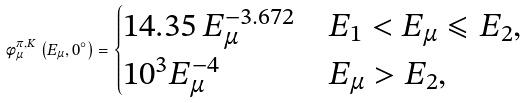Convert formula to latex. <formula><loc_0><loc_0><loc_500><loc_500>\phi _ { \mu } ^ { \pi , K } \left ( E _ { \mu } , 0 ^ { \circ } \right ) = \begin{cases} 1 4 . 3 5 \, E _ { \mu } ^ { - 3 . 6 7 2 } & \text {$E_{1}<E_{\mu}\leqslant E_{2}$} , \\ 1 0 ^ { 3 } E _ { \mu } ^ { - 4 } & \text {$E_{\mu}>E_{2}$} , \end{cases}</formula> 